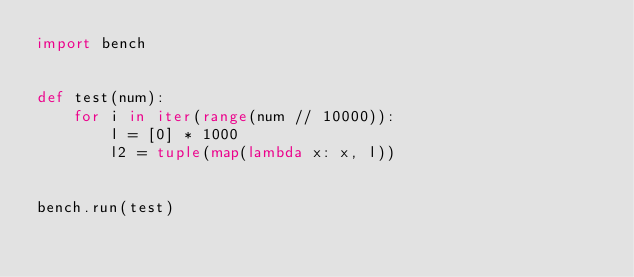<code> <loc_0><loc_0><loc_500><loc_500><_Python_>import bench


def test(num):
    for i in iter(range(num // 10000)):
        l = [0] * 1000
        l2 = tuple(map(lambda x: x, l))


bench.run(test)
</code> 